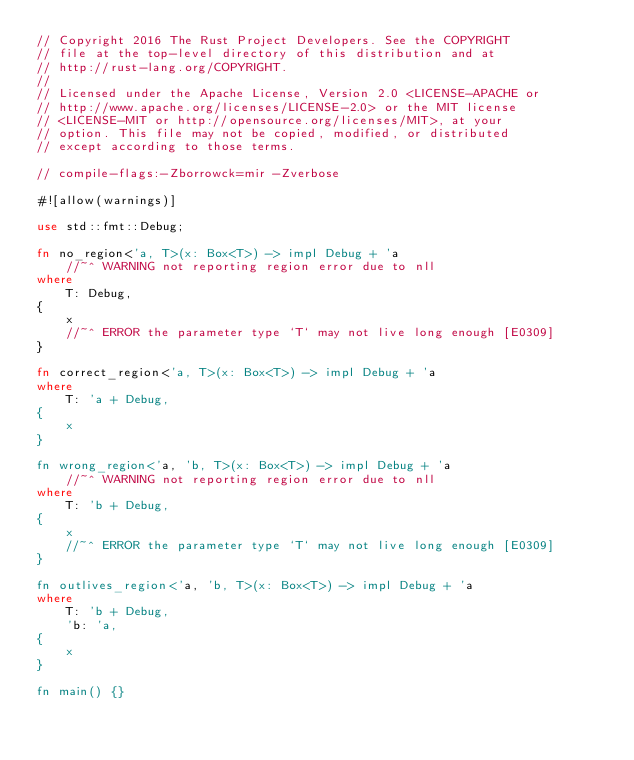<code> <loc_0><loc_0><loc_500><loc_500><_Rust_>// Copyright 2016 The Rust Project Developers. See the COPYRIGHT
// file at the top-level directory of this distribution and at
// http://rust-lang.org/COPYRIGHT.
//
// Licensed under the Apache License, Version 2.0 <LICENSE-APACHE or
// http://www.apache.org/licenses/LICENSE-2.0> or the MIT license
// <LICENSE-MIT or http://opensource.org/licenses/MIT>, at your
// option. This file may not be copied, modified, or distributed
// except according to those terms.

// compile-flags:-Zborrowck=mir -Zverbose

#![allow(warnings)]

use std::fmt::Debug;

fn no_region<'a, T>(x: Box<T>) -> impl Debug + 'a
    //~^ WARNING not reporting region error due to nll
where
    T: Debug,
{
    x
    //~^ ERROR the parameter type `T` may not live long enough [E0309]
}

fn correct_region<'a, T>(x: Box<T>) -> impl Debug + 'a
where
    T: 'a + Debug,
{
    x
}

fn wrong_region<'a, 'b, T>(x: Box<T>) -> impl Debug + 'a
    //~^ WARNING not reporting region error due to nll
where
    T: 'b + Debug,
{
    x
    //~^ ERROR the parameter type `T` may not live long enough [E0309]
}

fn outlives_region<'a, 'b, T>(x: Box<T>) -> impl Debug + 'a
where
    T: 'b + Debug,
    'b: 'a,
{
    x
}

fn main() {}
</code> 